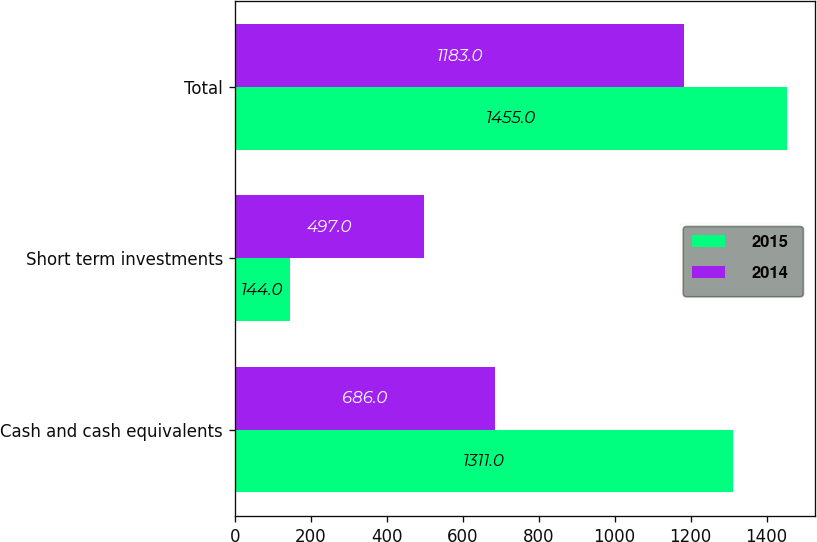Convert chart. <chart><loc_0><loc_0><loc_500><loc_500><stacked_bar_chart><ecel><fcel>Cash and cash equivalents<fcel>Short term investments<fcel>Total<nl><fcel>2015<fcel>1311<fcel>144<fcel>1455<nl><fcel>2014<fcel>686<fcel>497<fcel>1183<nl></chart> 